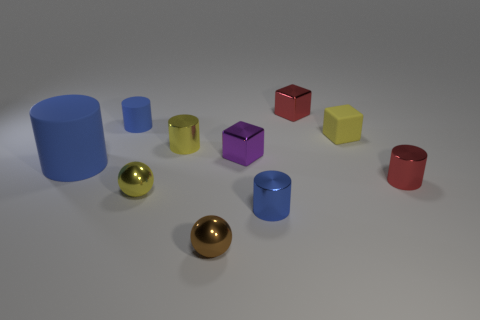Which of these objects stands out the most and why? The red cylinder commands attention due to its vibrant hue and prominence in the foreground. It contrasts sharply with the neutral background and the more subdued colors of the other shapes. Its position and color may be intentionally used to draw the viewer's eye as a focal point in this otherwise orderly collection of shapes. Does the red cylinder have any aesthetic or symbolic significance in this context? Aesthetically, the red cylinder injects energy and contrast into the scene, which could symbolize a point of interest or importance. Symbolically, red often conveys emotions such as passion or urgency, which might suggest the cylinder represents a key element within the context it was placed. However, without additional context, it remains a subject open to interpretation. 